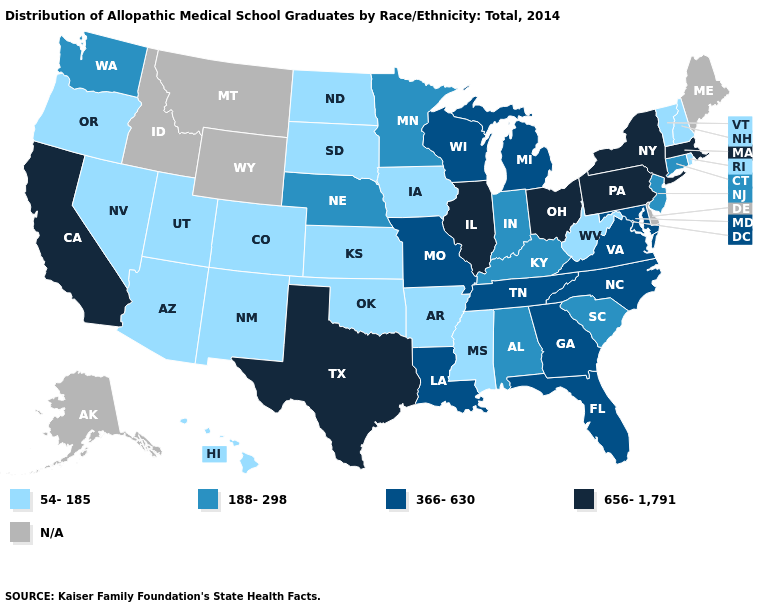Name the states that have a value in the range 656-1,791?
Write a very short answer. California, Illinois, Massachusetts, New York, Ohio, Pennsylvania, Texas. What is the value of Wisconsin?
Write a very short answer. 366-630. Does the first symbol in the legend represent the smallest category?
Quick response, please. Yes. What is the value of North Carolina?
Quick response, please. 366-630. Does Virginia have the highest value in the USA?
Write a very short answer. No. Which states have the lowest value in the USA?
Write a very short answer. Arizona, Arkansas, Colorado, Hawaii, Iowa, Kansas, Mississippi, Nevada, New Hampshire, New Mexico, North Dakota, Oklahoma, Oregon, Rhode Island, South Dakota, Utah, Vermont, West Virginia. What is the highest value in states that border North Carolina?
Concise answer only. 366-630. Does Vermont have the lowest value in the USA?
Concise answer only. Yes. What is the lowest value in the MidWest?
Short answer required. 54-185. Name the states that have a value in the range 188-298?
Quick response, please. Alabama, Connecticut, Indiana, Kentucky, Minnesota, Nebraska, New Jersey, South Carolina, Washington. Does Colorado have the highest value in the West?
Short answer required. No. Name the states that have a value in the range 54-185?
Answer briefly. Arizona, Arkansas, Colorado, Hawaii, Iowa, Kansas, Mississippi, Nevada, New Hampshire, New Mexico, North Dakota, Oklahoma, Oregon, Rhode Island, South Dakota, Utah, Vermont, West Virginia. What is the value of Minnesota?
Be succinct. 188-298. 